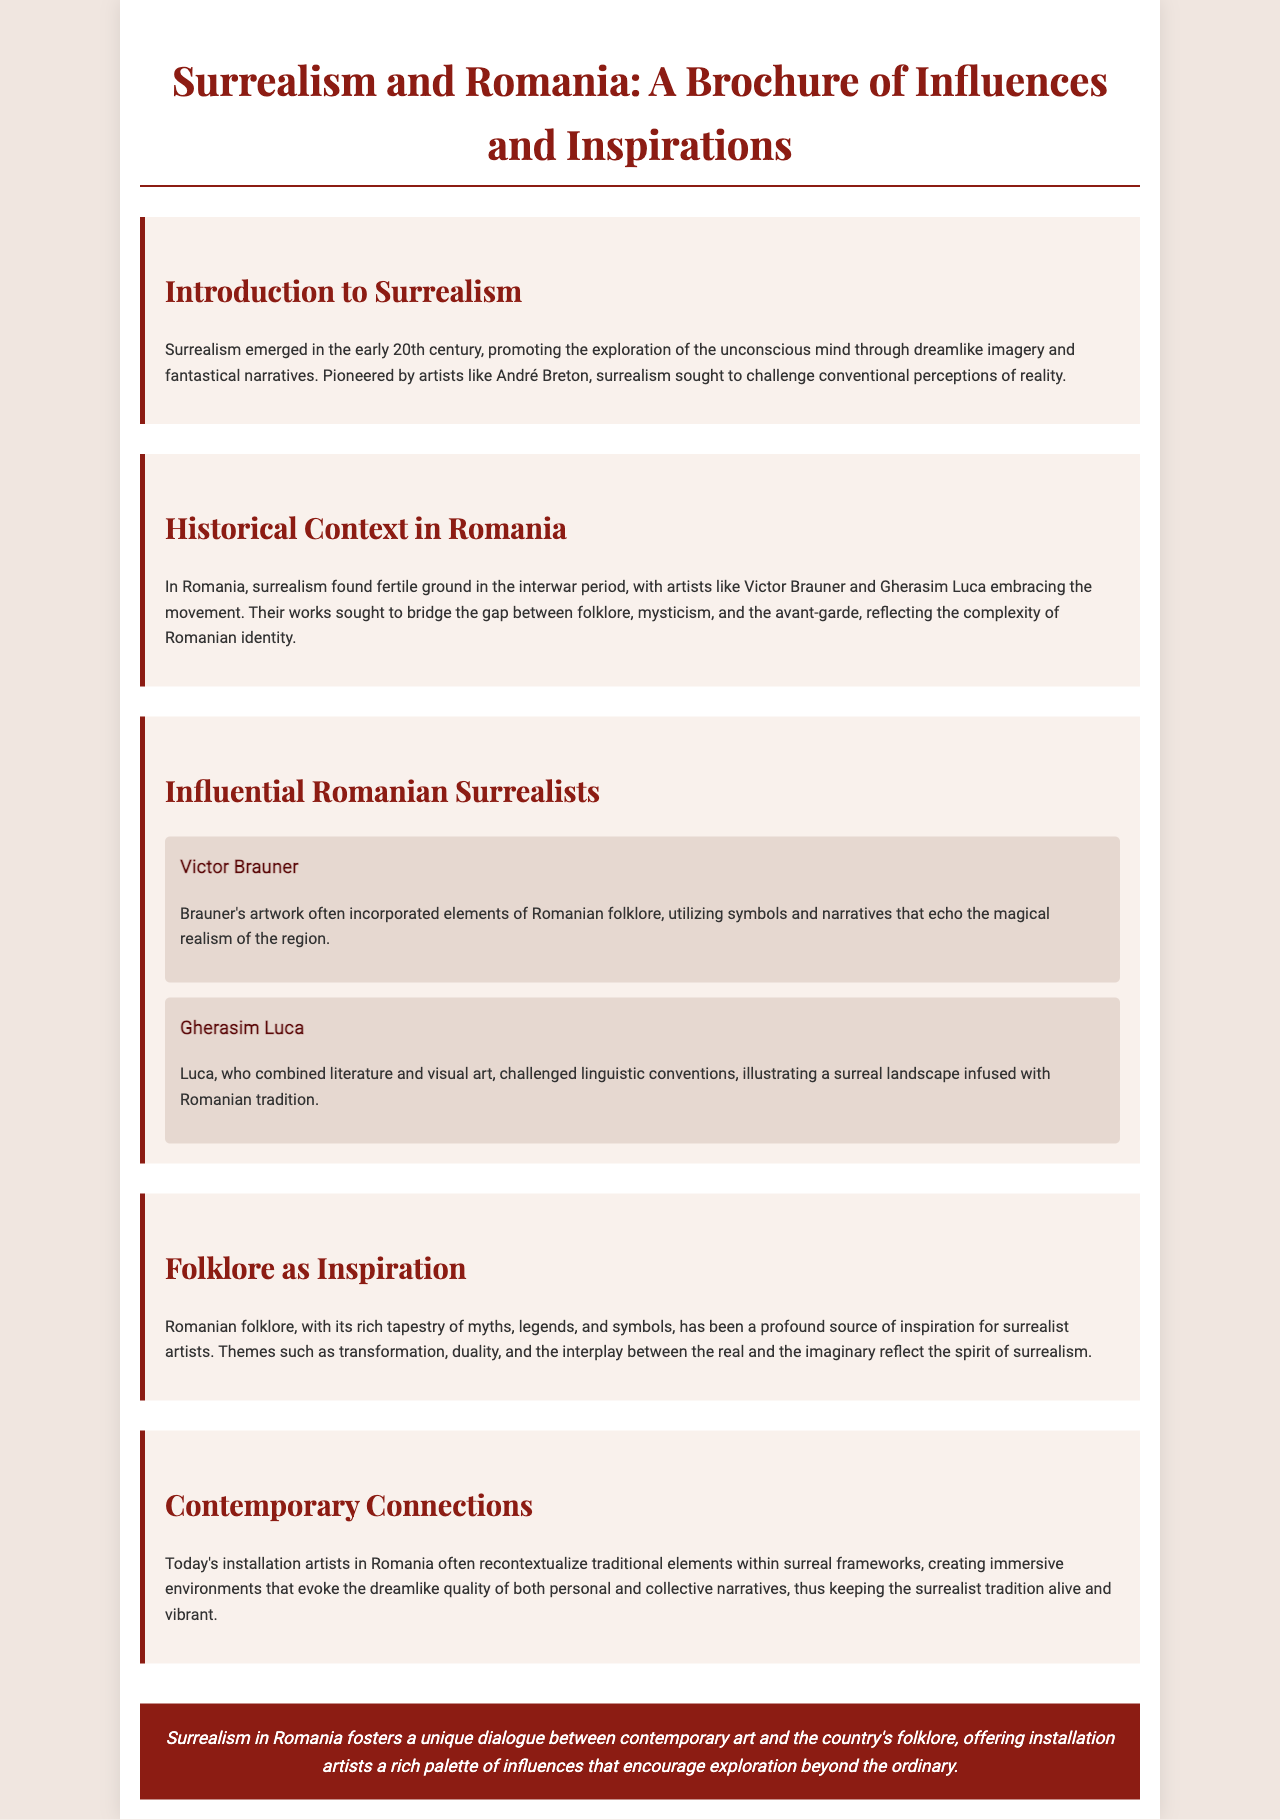What is surrealism? Surrealism is described in the document as a movement that promotes the exploration of the unconscious mind through dreamlike imagery and fantastical narratives.
Answer: exploration of the unconscious mind Who were the Romanian surrealists mentioned? The document lists Victor Brauner and Gherasim Luca as influential Romanian surrealists.
Answer: Victor Brauner and Gherasim Luca What did Victor Brauner incorporate into his artwork? Brauner's artwork incorporated elements of Romanian folklore and symbols that echo the region's magical realism.
Answer: Romanian folklore What themes in folklore inspire surrealist artists according to the document? The document highlights themes such as transformation, duality, and the interplay between the real and the imaginary as inspirations.
Answer: transformation, duality, interplay In what period did surrealism flourish in Romania? The historical context section specifies that surrealism found fertile ground in Romania during the interwar period.
Answer: interwar period What is the role of contemporary installation artists in Romania? The document states that contemporary installation artists often recontextualize traditional elements within surreal frameworks.
Answer: recontextualize traditional elements What element does the conclusion emphasize about the connection between surrealism and Romania? The conclusion emphasizes the unique dialogue between contemporary art and Romania's folklore.
Answer: unique dialogue How does the document describe the artworks of Gherasim Luca? Luca's works are described as illustrations of a surreal landscape infused with Romanian tradition.
Answer: surreal landscape infused with Romanian tradition 